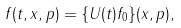Convert formula to latex. <formula><loc_0><loc_0><loc_500><loc_500>f ( t , x , p ) = \{ U ( t ) f _ { 0 } \} ( x , p ) ,</formula> 